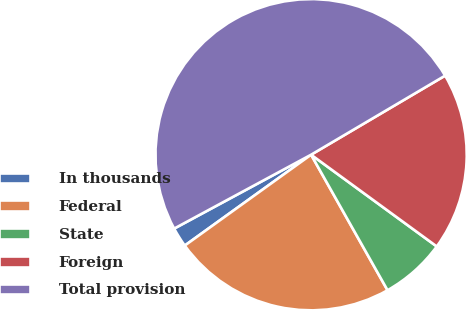Convert chart to OTSL. <chart><loc_0><loc_0><loc_500><loc_500><pie_chart><fcel>In thousands<fcel>Federal<fcel>State<fcel>Foreign<fcel>Total provision<nl><fcel>2.05%<fcel>23.25%<fcel>6.79%<fcel>18.52%<fcel>49.39%<nl></chart> 